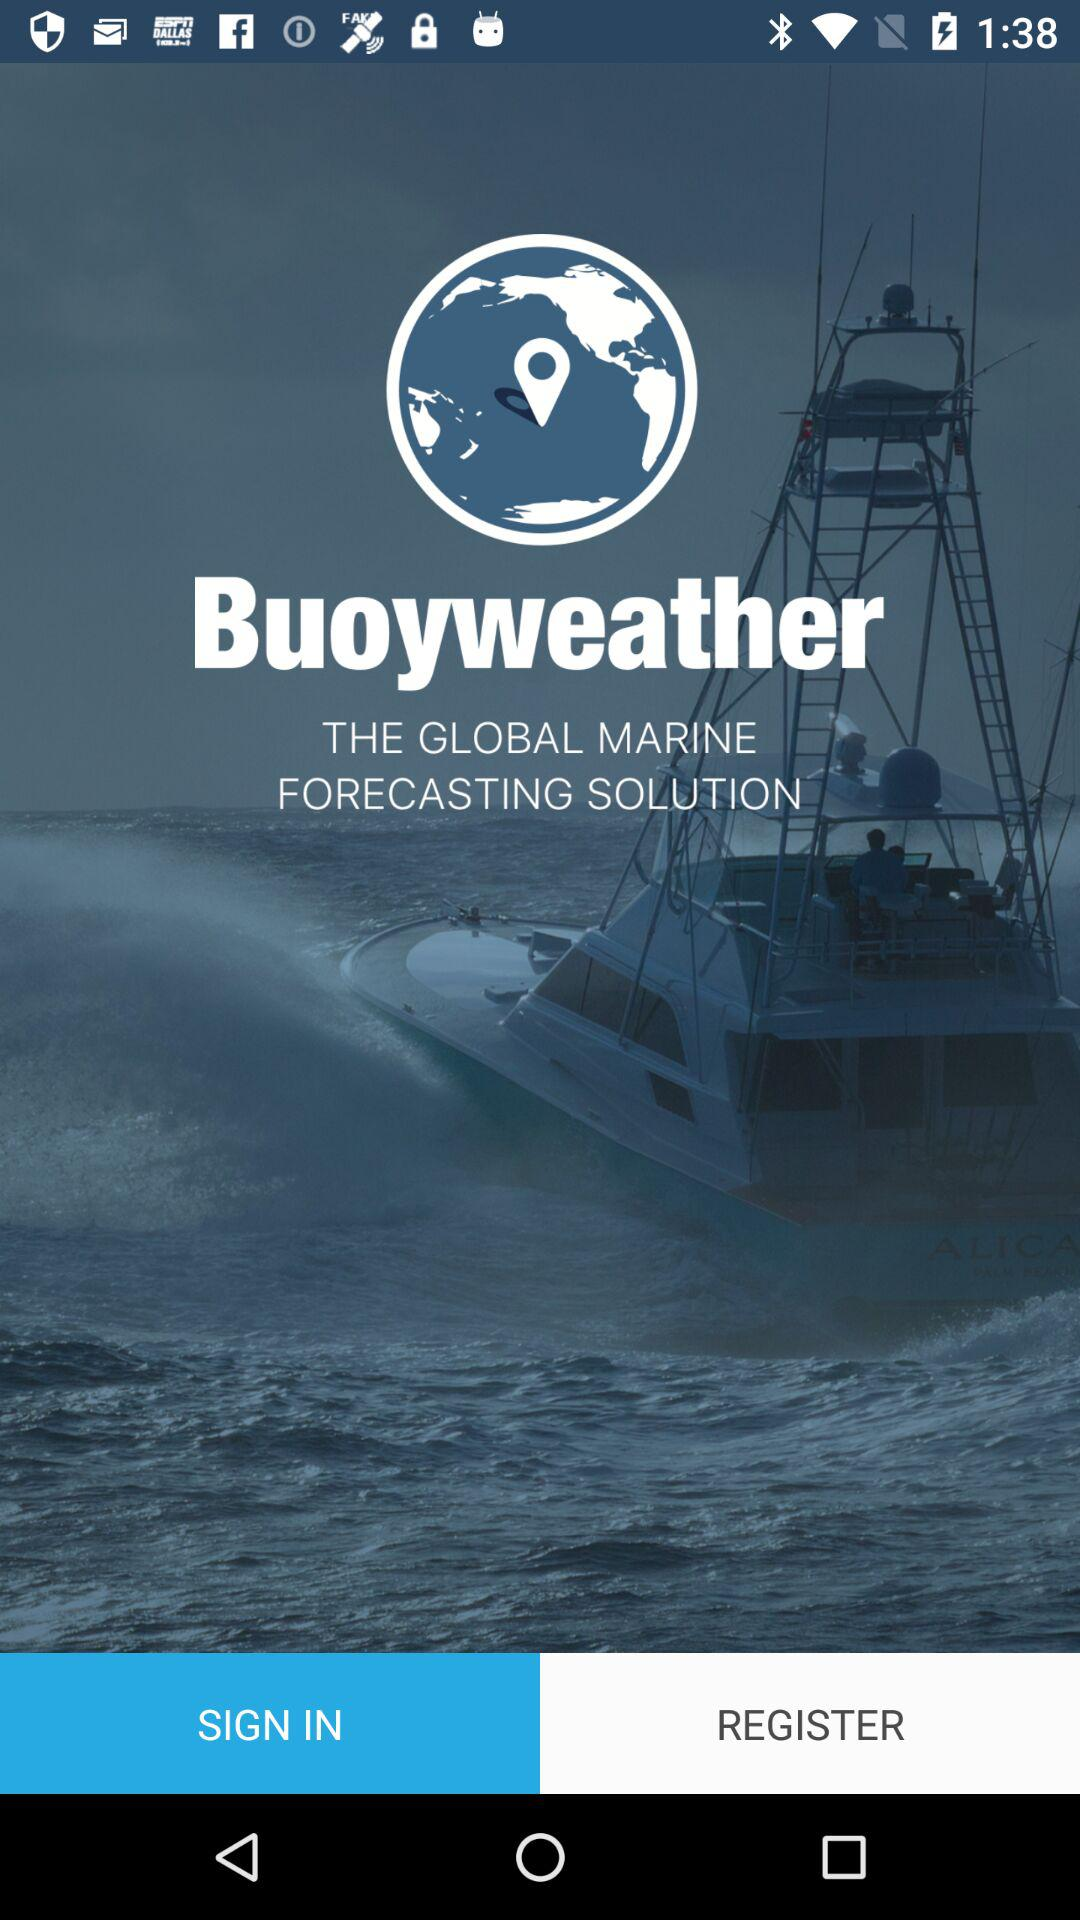What is the application name? The application name is "Buoyweather". 